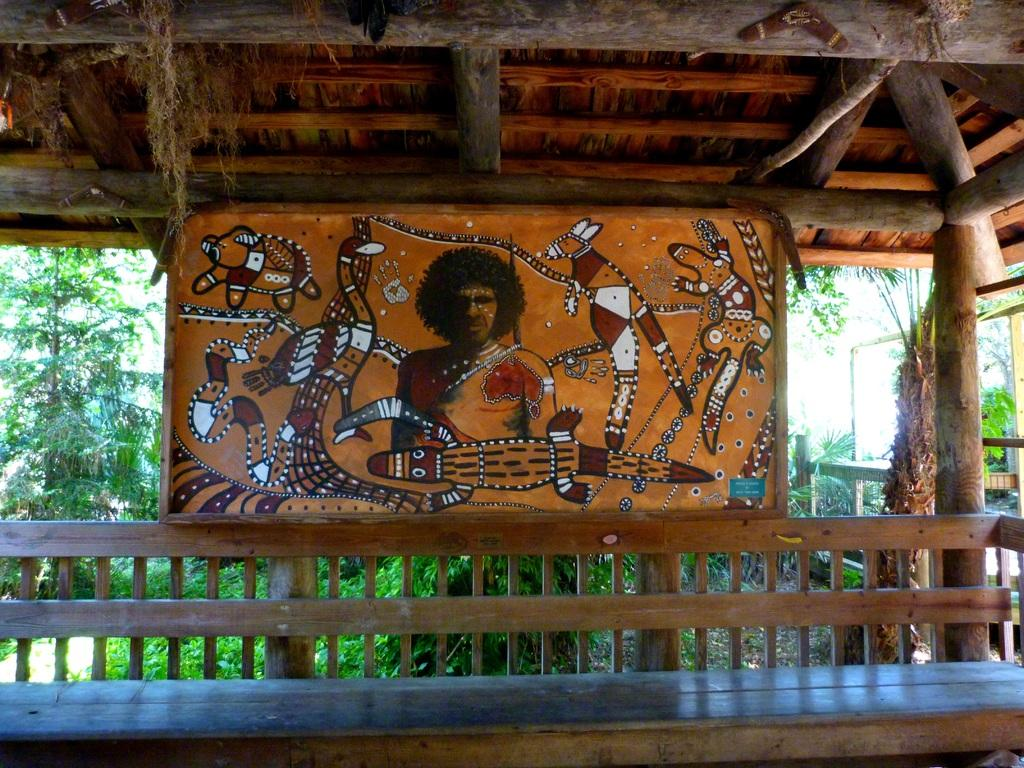What is the main object in the image? There is a board in the image. What type of furniture is present in the image? There is a wooden bench in the image. What natural elements can be seen in the image? There are trees in the image. What type of building is visible in the image? There is a wooden house in the image. What type of animals can be seen at the zoo in the image? There is no zoo present in the image, so it is not possible to determine what animals might be seen there. What direction should we follow according to the sign in the image? There is no sign present in the image, so it is not possible to provide directions based on a sign. 